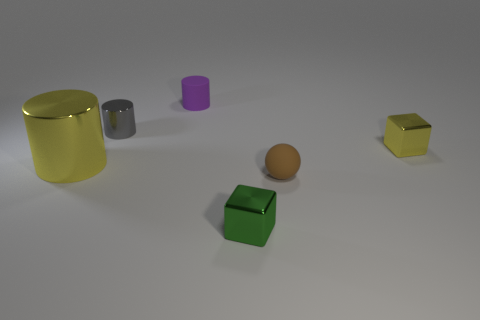Can you describe the colors of the objects? Certainly! There are various colored objects in the image: a large yellow cylindrical object, a smaller grey cylinder, a purple cylinder that looks smaller in size possibly due to perspective, an orange sphere, and two cubes, one green and one yellow. 